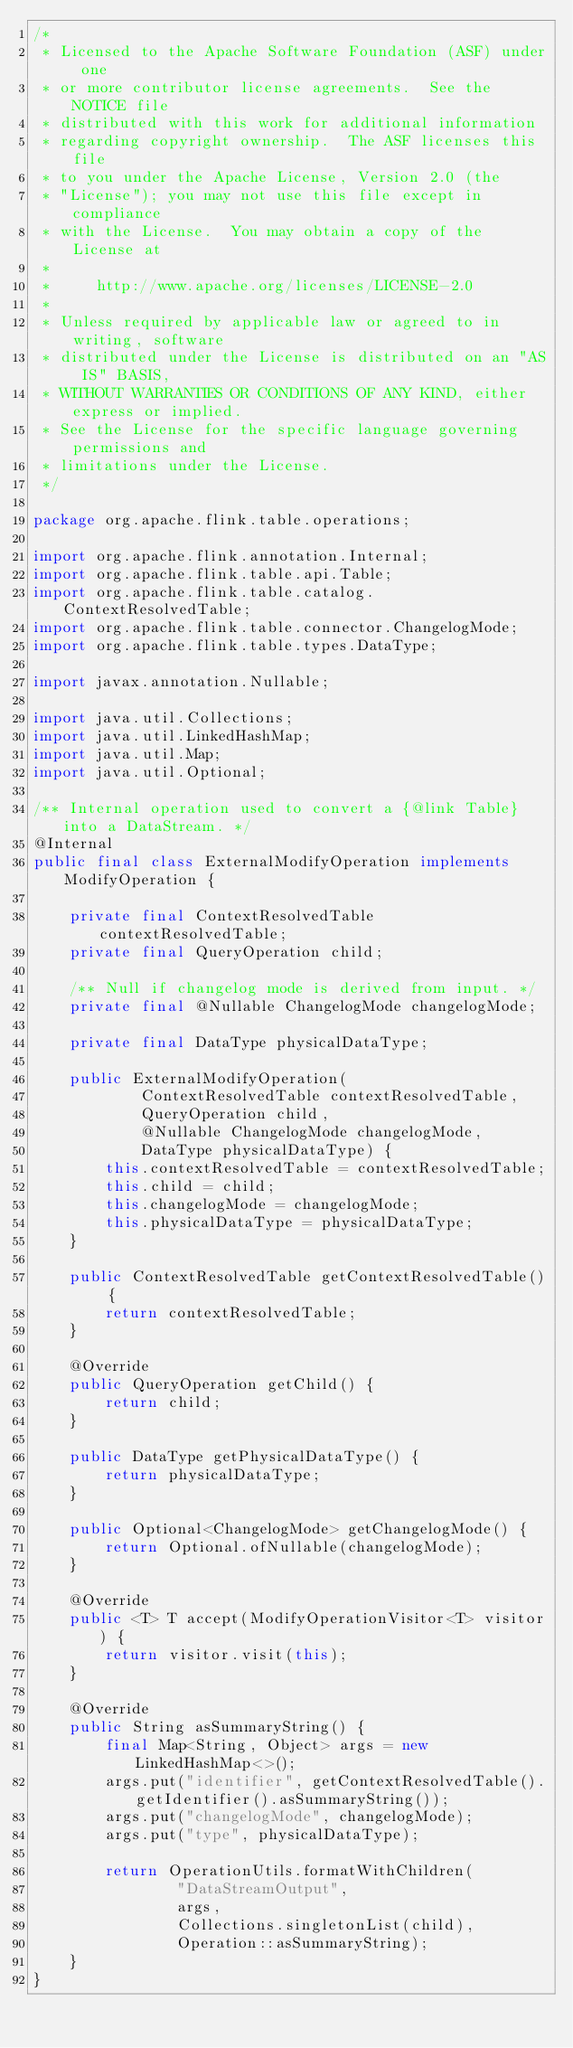Convert code to text. <code><loc_0><loc_0><loc_500><loc_500><_Java_>/*
 * Licensed to the Apache Software Foundation (ASF) under one
 * or more contributor license agreements.  See the NOTICE file
 * distributed with this work for additional information
 * regarding copyright ownership.  The ASF licenses this file
 * to you under the Apache License, Version 2.0 (the
 * "License"); you may not use this file except in compliance
 * with the License.  You may obtain a copy of the License at
 *
 *     http://www.apache.org/licenses/LICENSE-2.0
 *
 * Unless required by applicable law or agreed to in writing, software
 * distributed under the License is distributed on an "AS IS" BASIS,
 * WITHOUT WARRANTIES OR CONDITIONS OF ANY KIND, either express or implied.
 * See the License for the specific language governing permissions and
 * limitations under the License.
 */

package org.apache.flink.table.operations;

import org.apache.flink.annotation.Internal;
import org.apache.flink.table.api.Table;
import org.apache.flink.table.catalog.ContextResolvedTable;
import org.apache.flink.table.connector.ChangelogMode;
import org.apache.flink.table.types.DataType;

import javax.annotation.Nullable;

import java.util.Collections;
import java.util.LinkedHashMap;
import java.util.Map;
import java.util.Optional;

/** Internal operation used to convert a {@link Table} into a DataStream. */
@Internal
public final class ExternalModifyOperation implements ModifyOperation {

    private final ContextResolvedTable contextResolvedTable;
    private final QueryOperation child;

    /** Null if changelog mode is derived from input. */
    private final @Nullable ChangelogMode changelogMode;

    private final DataType physicalDataType;

    public ExternalModifyOperation(
            ContextResolvedTable contextResolvedTable,
            QueryOperation child,
            @Nullable ChangelogMode changelogMode,
            DataType physicalDataType) {
        this.contextResolvedTable = contextResolvedTable;
        this.child = child;
        this.changelogMode = changelogMode;
        this.physicalDataType = physicalDataType;
    }

    public ContextResolvedTable getContextResolvedTable() {
        return contextResolvedTable;
    }

    @Override
    public QueryOperation getChild() {
        return child;
    }

    public DataType getPhysicalDataType() {
        return physicalDataType;
    }

    public Optional<ChangelogMode> getChangelogMode() {
        return Optional.ofNullable(changelogMode);
    }

    @Override
    public <T> T accept(ModifyOperationVisitor<T> visitor) {
        return visitor.visit(this);
    }

    @Override
    public String asSummaryString() {
        final Map<String, Object> args = new LinkedHashMap<>();
        args.put("identifier", getContextResolvedTable().getIdentifier().asSummaryString());
        args.put("changelogMode", changelogMode);
        args.put("type", physicalDataType);

        return OperationUtils.formatWithChildren(
                "DataStreamOutput",
                args,
                Collections.singletonList(child),
                Operation::asSummaryString);
    }
}
</code> 